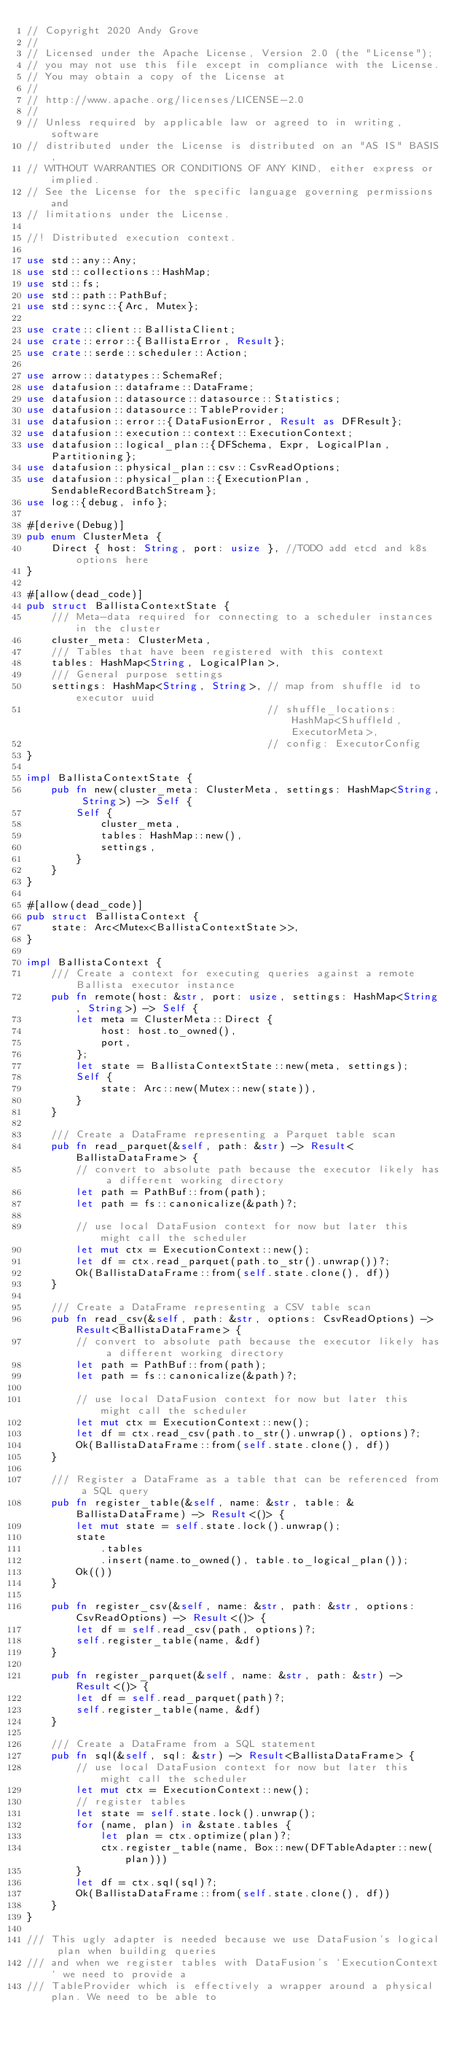Convert code to text. <code><loc_0><loc_0><loc_500><loc_500><_Rust_>// Copyright 2020 Andy Grove
//
// Licensed under the Apache License, Version 2.0 (the "License");
// you may not use this file except in compliance with the License.
// You may obtain a copy of the License at
//
// http://www.apache.org/licenses/LICENSE-2.0
//
// Unless required by applicable law or agreed to in writing, software
// distributed under the License is distributed on an "AS IS" BASIS,
// WITHOUT WARRANTIES OR CONDITIONS OF ANY KIND, either express or implied.
// See the License for the specific language governing permissions and
// limitations under the License.

//! Distributed execution context.

use std::any::Any;
use std::collections::HashMap;
use std::fs;
use std::path::PathBuf;
use std::sync::{Arc, Mutex};

use crate::client::BallistaClient;
use crate::error::{BallistaError, Result};
use crate::serde::scheduler::Action;

use arrow::datatypes::SchemaRef;
use datafusion::dataframe::DataFrame;
use datafusion::datasource::datasource::Statistics;
use datafusion::datasource::TableProvider;
use datafusion::error::{DataFusionError, Result as DFResult};
use datafusion::execution::context::ExecutionContext;
use datafusion::logical_plan::{DFSchema, Expr, LogicalPlan, Partitioning};
use datafusion::physical_plan::csv::CsvReadOptions;
use datafusion::physical_plan::{ExecutionPlan, SendableRecordBatchStream};
use log::{debug, info};

#[derive(Debug)]
pub enum ClusterMeta {
    Direct { host: String, port: usize }, //TODO add etcd and k8s options here
}

#[allow(dead_code)]
pub struct BallistaContextState {
    /// Meta-data required for connecting to a scheduler instances in the cluster
    cluster_meta: ClusterMeta,
    /// Tables that have been registered with this context
    tables: HashMap<String, LogicalPlan>,
    /// General purpose settings
    settings: HashMap<String, String>, // map from shuffle id to executor uuid
                                       // shuffle_locations: HashMap<ShuffleId, ExecutorMeta>,
                                       // config: ExecutorConfig
}

impl BallistaContextState {
    pub fn new(cluster_meta: ClusterMeta, settings: HashMap<String, String>) -> Self {
        Self {
            cluster_meta,
            tables: HashMap::new(),
            settings,
        }
    }
}

#[allow(dead_code)]
pub struct BallistaContext {
    state: Arc<Mutex<BallistaContextState>>,
}

impl BallistaContext {
    /// Create a context for executing queries against a remote Ballista executor instance
    pub fn remote(host: &str, port: usize, settings: HashMap<String, String>) -> Self {
        let meta = ClusterMeta::Direct {
            host: host.to_owned(),
            port,
        };
        let state = BallistaContextState::new(meta, settings);
        Self {
            state: Arc::new(Mutex::new(state)),
        }
    }

    /// Create a DataFrame representing a Parquet table scan
    pub fn read_parquet(&self, path: &str) -> Result<BallistaDataFrame> {
        // convert to absolute path because the executor likely has a different working directory
        let path = PathBuf::from(path);
        let path = fs::canonicalize(&path)?;

        // use local DataFusion context for now but later this might call the scheduler
        let mut ctx = ExecutionContext::new();
        let df = ctx.read_parquet(path.to_str().unwrap())?;
        Ok(BallistaDataFrame::from(self.state.clone(), df))
    }

    /// Create a DataFrame representing a CSV table scan
    pub fn read_csv(&self, path: &str, options: CsvReadOptions) -> Result<BallistaDataFrame> {
        // convert to absolute path because the executor likely has a different working directory
        let path = PathBuf::from(path);
        let path = fs::canonicalize(&path)?;

        // use local DataFusion context for now but later this might call the scheduler
        let mut ctx = ExecutionContext::new();
        let df = ctx.read_csv(path.to_str().unwrap(), options)?;
        Ok(BallistaDataFrame::from(self.state.clone(), df))
    }

    /// Register a DataFrame as a table that can be referenced from a SQL query
    pub fn register_table(&self, name: &str, table: &BallistaDataFrame) -> Result<()> {
        let mut state = self.state.lock().unwrap();
        state
            .tables
            .insert(name.to_owned(), table.to_logical_plan());
        Ok(())
    }

    pub fn register_csv(&self, name: &str, path: &str, options: CsvReadOptions) -> Result<()> {
        let df = self.read_csv(path, options)?;
        self.register_table(name, &df)
    }

    pub fn register_parquet(&self, name: &str, path: &str) -> Result<()> {
        let df = self.read_parquet(path)?;
        self.register_table(name, &df)
    }

    /// Create a DataFrame from a SQL statement
    pub fn sql(&self, sql: &str) -> Result<BallistaDataFrame> {
        // use local DataFusion context for now but later this might call the scheduler
        let mut ctx = ExecutionContext::new();
        // register tables
        let state = self.state.lock().unwrap();
        for (name, plan) in &state.tables {
            let plan = ctx.optimize(plan)?;
            ctx.register_table(name, Box::new(DFTableAdapter::new(plan)))
        }
        let df = ctx.sql(sql)?;
        Ok(BallistaDataFrame::from(self.state.clone(), df))
    }
}

/// This ugly adapter is needed because we use DataFusion's logical plan when building queries
/// and when we register tables with DataFusion's `ExecutionContext` we need to provide a
/// TableProvider which is effectively a wrapper around a physical plan. We need to be able to</code> 